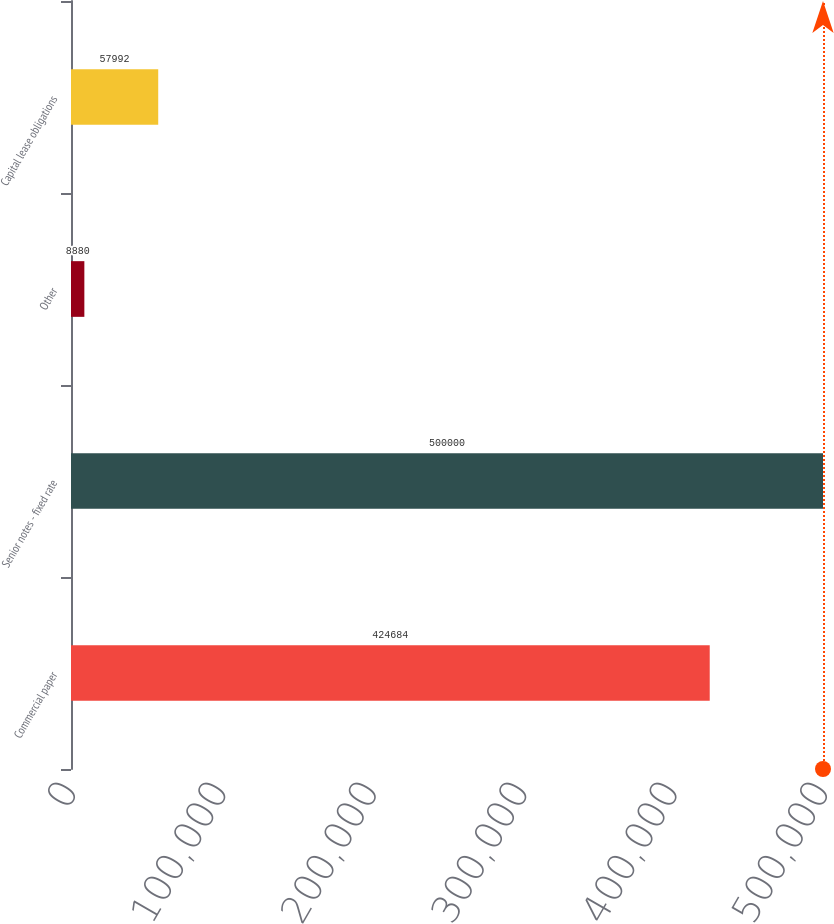Convert chart to OTSL. <chart><loc_0><loc_0><loc_500><loc_500><bar_chart><fcel>Commercial paper<fcel>Senior notes - fixed rate<fcel>Other<fcel>Capital lease obligations<nl><fcel>424684<fcel>500000<fcel>8880<fcel>57992<nl></chart> 